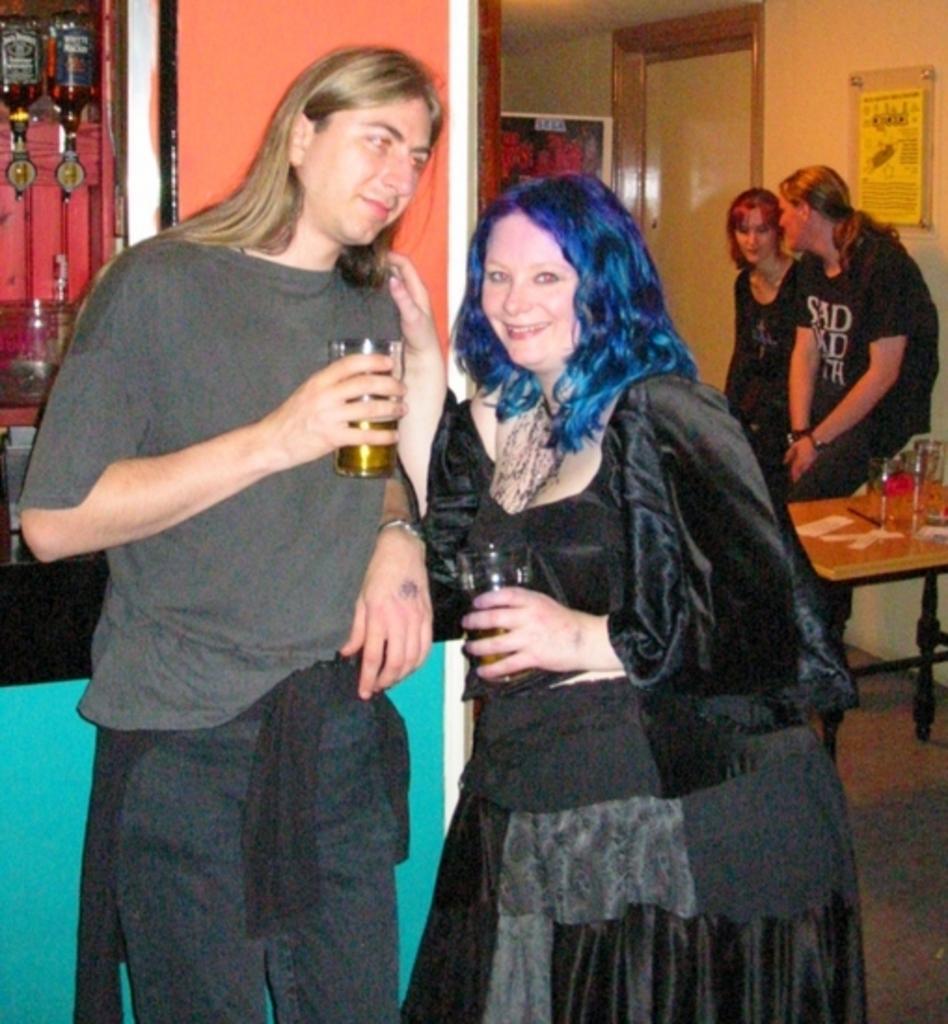Describe this image in one or two sentences. In the center of the image we can see two people are standing and holding the glasses. In the background of the image we can see the wall, door, boards on the wall, bottles, table and two people are standing. On the table we can see the glasses, papers. In the bottom right corner we can see the floor. At the top of the image we can see the roof. 